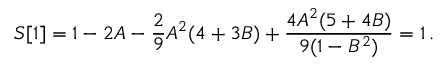Convert formula to latex. <formula><loc_0><loc_0><loc_500><loc_500>S [ 1 ] = 1 - 2 A - \frac { 2 } { 9 } A ^ { 2 } ( 4 + 3 B ) + \frac { 4 A ^ { 2 } ( 5 + 4 B ) } { 9 ( 1 - B ^ { 2 } ) } = 1 \, .</formula> 